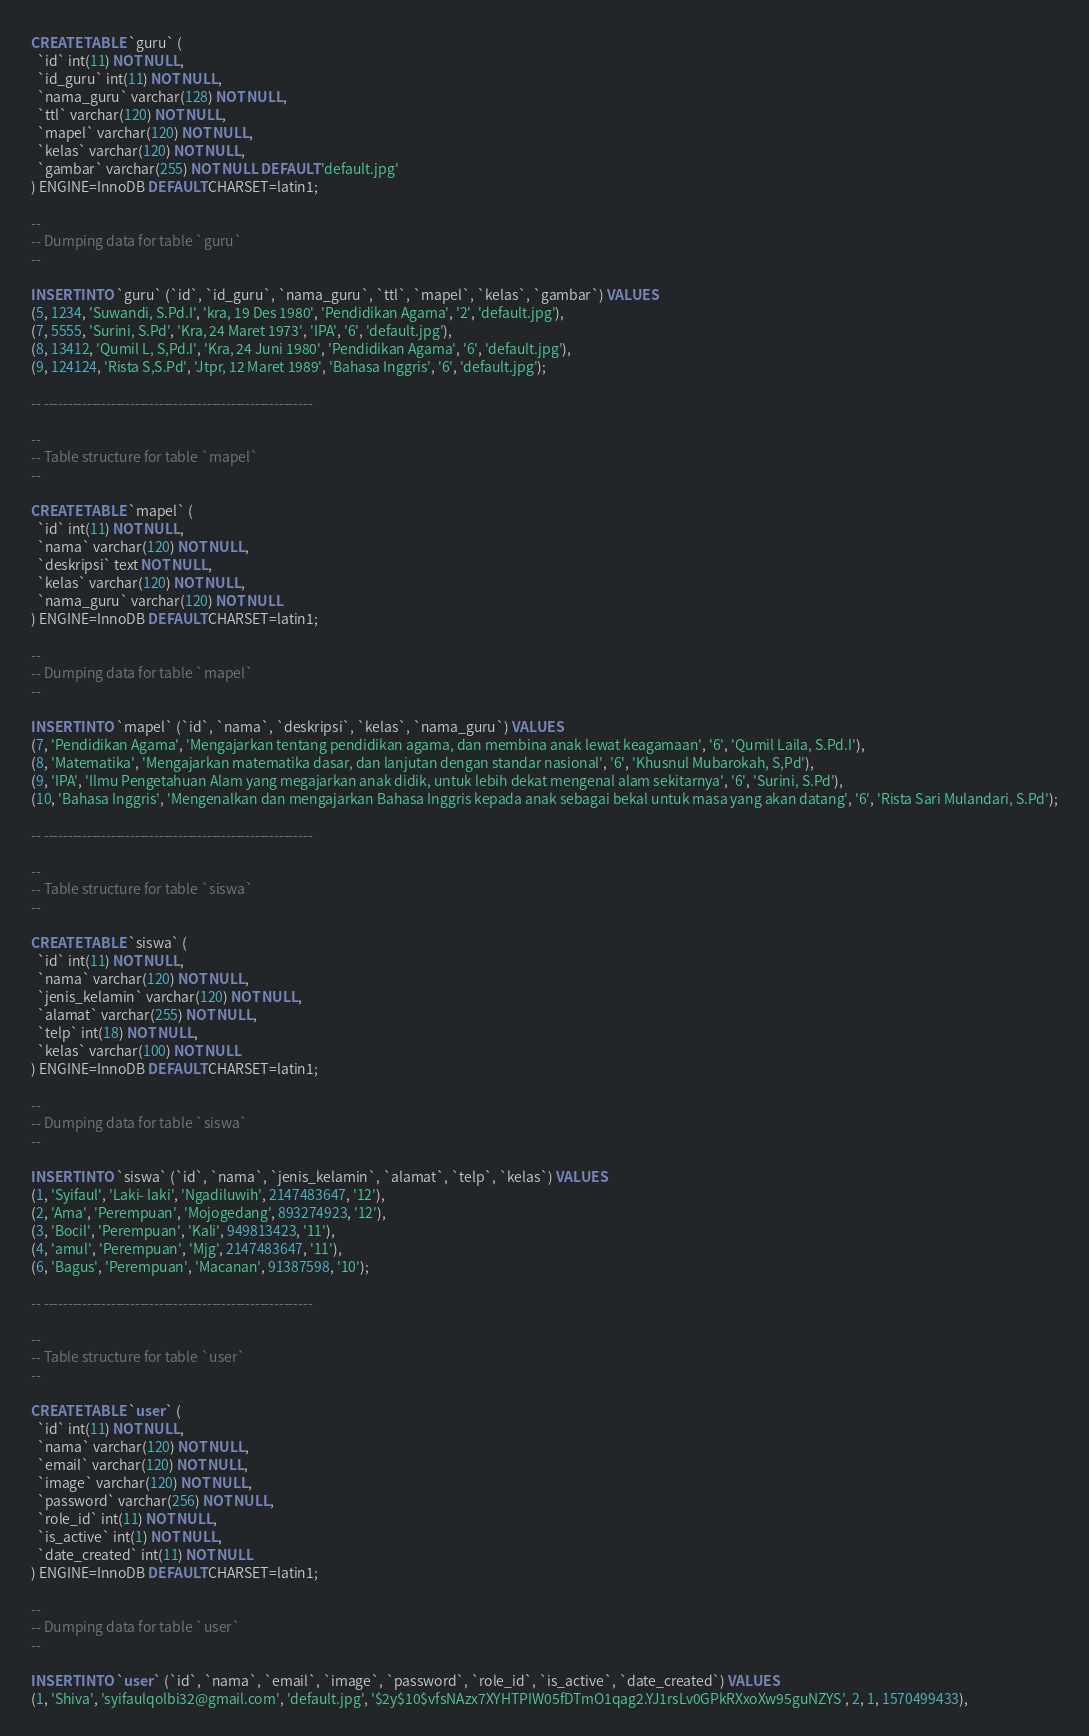<code> <loc_0><loc_0><loc_500><loc_500><_SQL_>CREATE TABLE `guru` (
  `id` int(11) NOT NULL,
  `id_guru` int(11) NOT NULL,
  `nama_guru` varchar(128) NOT NULL,
  `ttl` varchar(120) NOT NULL,
  `mapel` varchar(120) NOT NULL,
  `kelas` varchar(120) NOT NULL,
  `gambar` varchar(255) NOT NULL DEFAULT 'default.jpg'
) ENGINE=InnoDB DEFAULT CHARSET=latin1;

--
-- Dumping data for table `guru`
--

INSERT INTO `guru` (`id`, `id_guru`, `nama_guru`, `ttl`, `mapel`, `kelas`, `gambar`) VALUES
(5, 1234, 'Suwandi, S.Pd.I', 'kra, 19 Des 1980', 'Pendidikan Agama', '2', 'default.jpg'),
(7, 5555, 'Surini, S.Pd', 'Kra, 24 Maret 1973', 'IPA', '6', 'default.jpg'),
(8, 13412, 'Qumil L, S,Pd.I', 'Kra, 24 Juni 1980', 'Pendidikan Agama', '6', 'default.jpg'),
(9, 124124, 'Rista S,S.Pd', 'Jtpr, 12 Maret 1989', 'Bahasa Inggris', '6', 'default.jpg');

-- --------------------------------------------------------

--
-- Table structure for table `mapel`
--

CREATE TABLE `mapel` (
  `id` int(11) NOT NULL,
  `nama` varchar(120) NOT NULL,
  `deskripsi` text NOT NULL,
  `kelas` varchar(120) NOT NULL,
  `nama_guru` varchar(120) NOT NULL
) ENGINE=InnoDB DEFAULT CHARSET=latin1;

--
-- Dumping data for table `mapel`
--

INSERT INTO `mapel` (`id`, `nama`, `deskripsi`, `kelas`, `nama_guru`) VALUES
(7, 'Pendidikan Agama', 'Mengajarkan tentang pendidikan agama, dan membina anak lewat keagamaan', '6', 'Qumil Laila, S.Pd.I'),
(8, 'Matematika', 'Mengajarkan matematika dasar, dan lanjutan dengan standar nasional', '6', 'Khusnul Mubarokah, S,Pd'),
(9, 'IPA', 'Ilmu Pengetahuan Alam yang megajarkan anak didik, untuk lebih dekat mengenal alam sekitarnya', '6', 'Surini, S.Pd'),
(10, 'Bahasa Inggris', 'Mengenalkan dan mengajarkan Bahasa Inggris kepada anak sebagai bekal untuk masa yang akan datang', '6', 'Rista Sari Mulandari, S.Pd');

-- --------------------------------------------------------

--
-- Table structure for table `siswa`
--

CREATE TABLE `siswa` (
  `id` int(11) NOT NULL,
  `nama` varchar(120) NOT NULL,
  `jenis_kelamin` varchar(120) NOT NULL,
  `alamat` varchar(255) NOT NULL,
  `telp` int(18) NOT NULL,
  `kelas` varchar(100) NOT NULL
) ENGINE=InnoDB DEFAULT CHARSET=latin1;

--
-- Dumping data for table `siswa`
--

INSERT INTO `siswa` (`id`, `nama`, `jenis_kelamin`, `alamat`, `telp`, `kelas`) VALUES
(1, 'Syifaul', 'Laki- laki', 'Ngadiluwih', 2147483647, '12'),
(2, 'Ama', 'Perempuan', 'Mojogedang', 893274923, '12'),
(3, 'Bocil', 'Perempuan', 'Kali', 949813423, '11'),
(4, 'amul', 'Perempuan', 'Mjg', 2147483647, '11'),
(6, 'Bagus', 'Perempuan', 'Macanan', 91387598, '10');

-- --------------------------------------------------------

--
-- Table structure for table `user`
--

CREATE TABLE `user` (
  `id` int(11) NOT NULL,
  `nama` varchar(120) NOT NULL,
  `email` varchar(120) NOT NULL,
  `image` varchar(120) NOT NULL,
  `password` varchar(256) NOT NULL,
  `role_id` int(11) NOT NULL,
  `is_active` int(1) NOT NULL,
  `date_created` int(11) NOT NULL
) ENGINE=InnoDB DEFAULT CHARSET=latin1;

--
-- Dumping data for table `user`
--

INSERT INTO `user` (`id`, `nama`, `email`, `image`, `password`, `role_id`, `is_active`, `date_created`) VALUES
(1, 'Shiva', 'syifaulqolbi32@gmail.com', 'default.jpg', '$2y$10$vfsNAzx7XYHTPIW05fDTmO1qag2.YJ1rsLv0GPkRXxoXw95guNZYS', 2, 1, 1570499433),</code> 